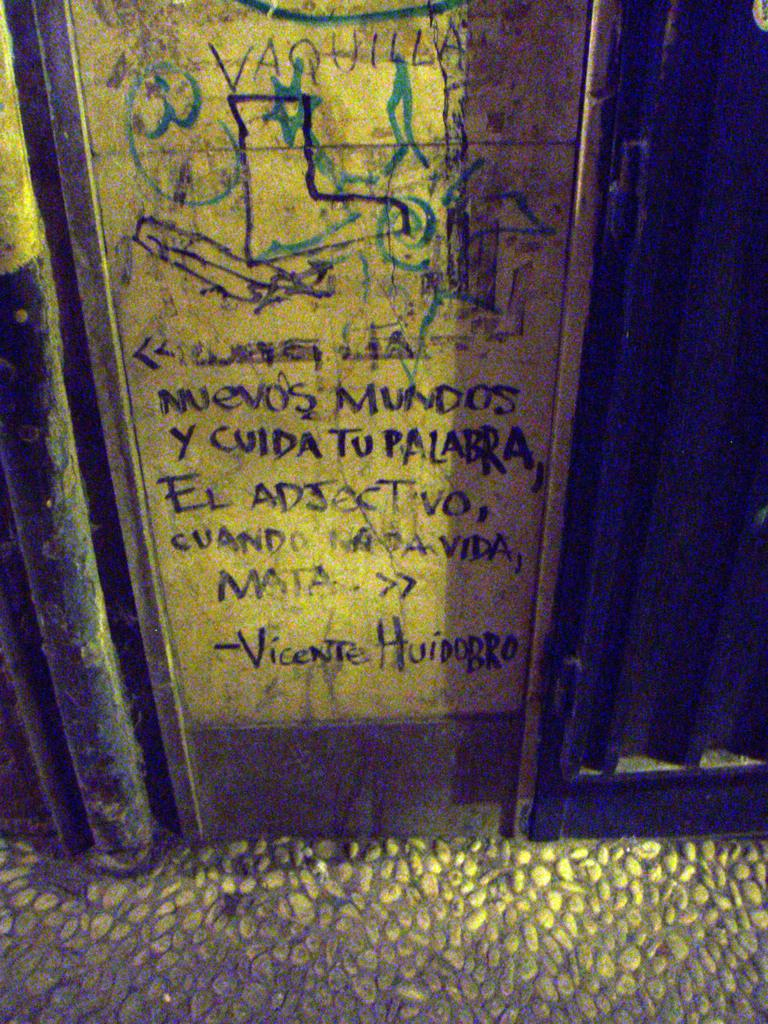<image>
Give a short and clear explanation of the subsequent image. A portion of a wall is scrawled on by someone named Vicente. 